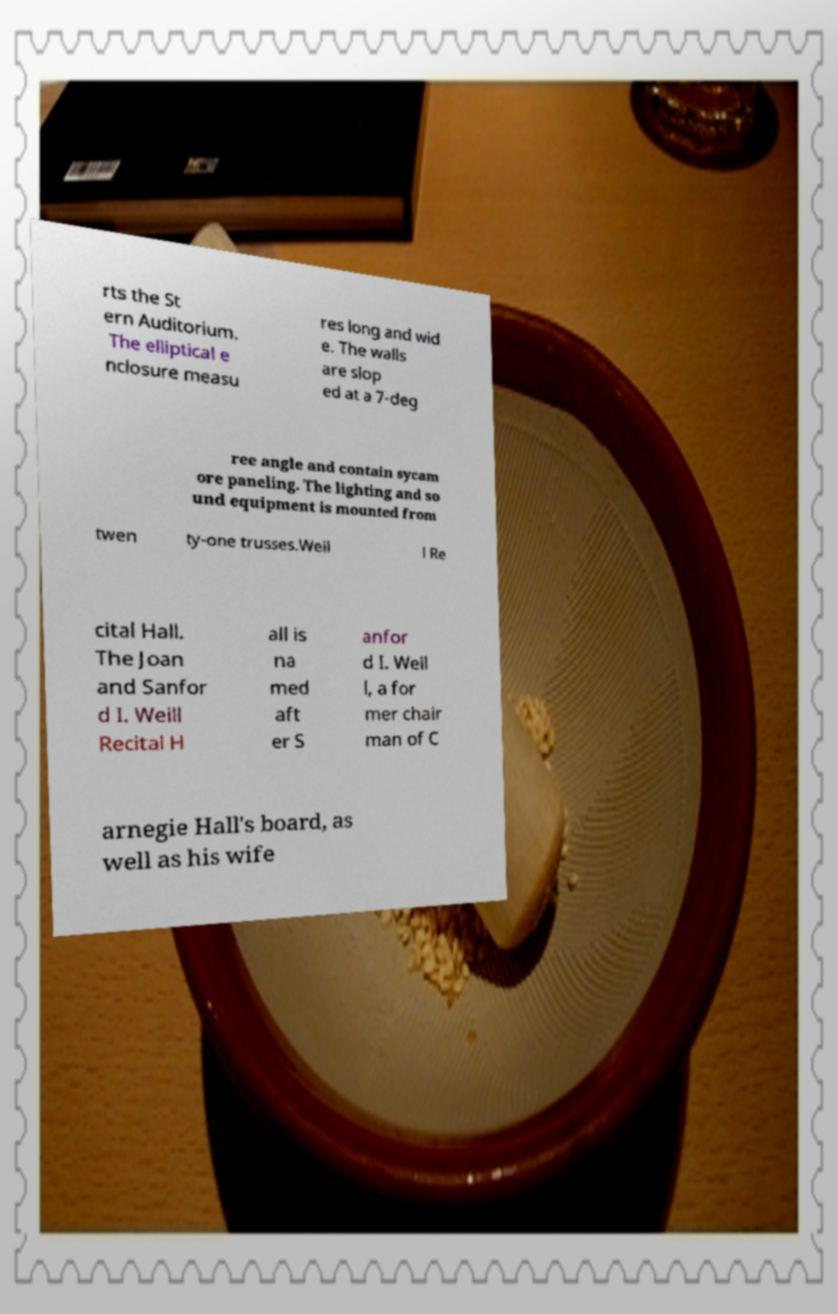Can you read and provide the text displayed in the image?This photo seems to have some interesting text. Can you extract and type it out for me? rts the St ern Auditorium. The elliptical e nclosure measu res long and wid e. The walls are slop ed at a 7-deg ree angle and contain sycam ore paneling. The lighting and so und equipment is mounted from twen ty-one trusses.Weil l Re cital Hall. The Joan and Sanfor d I. Weill Recital H all is na med aft er S anfor d I. Weil l, a for mer chair man of C arnegie Hall's board, as well as his wife 